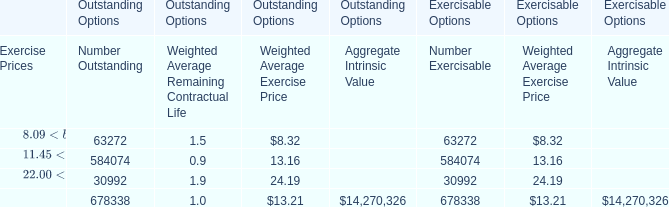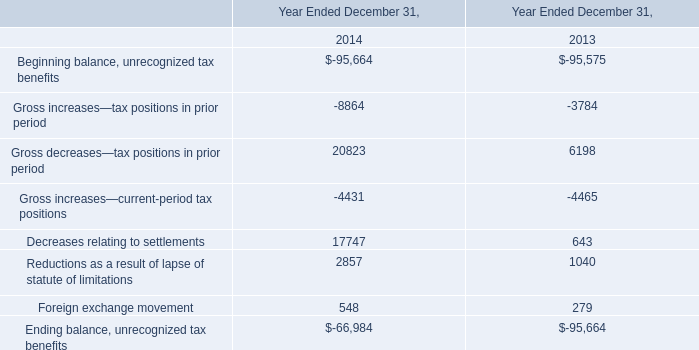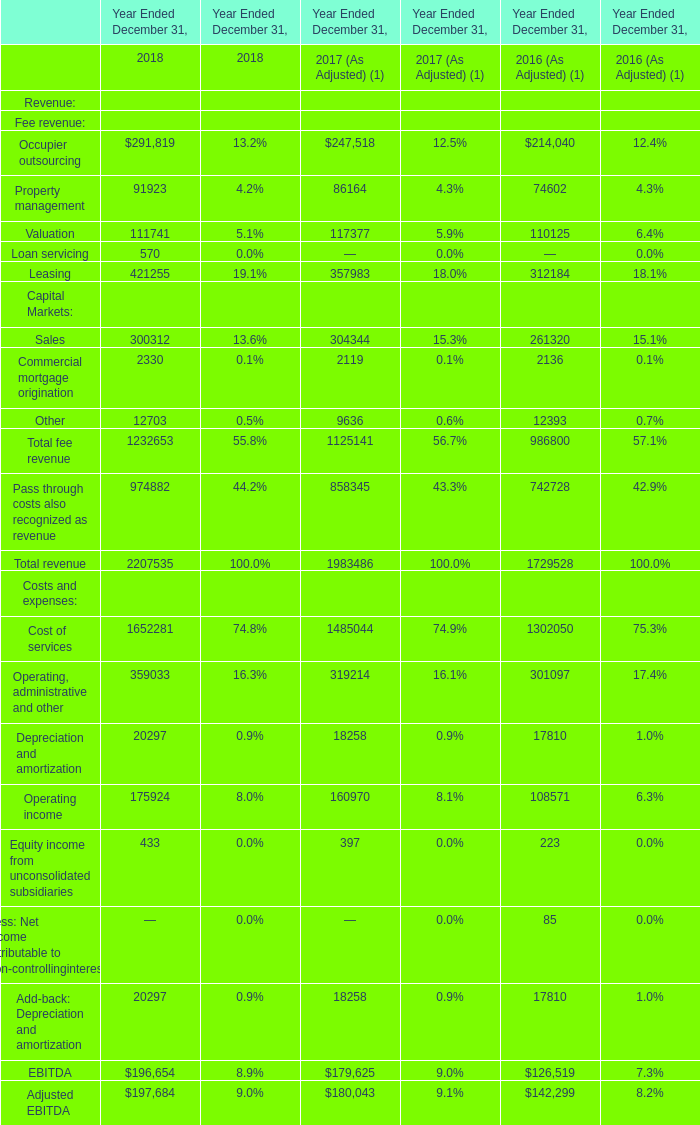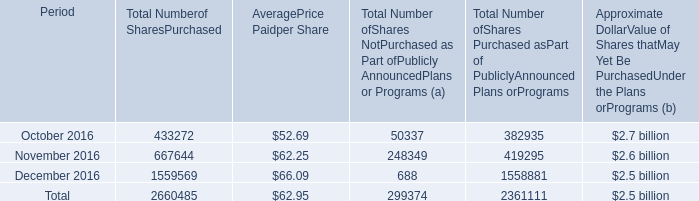What is the average increasing rate of Total revenue between 2017 and 2018? 
Computations: ((((1729528 - 1983486) / 1983486) + ((1983486 - 2207535) / 2207535)) / 2)
Answer: -0.11476. 